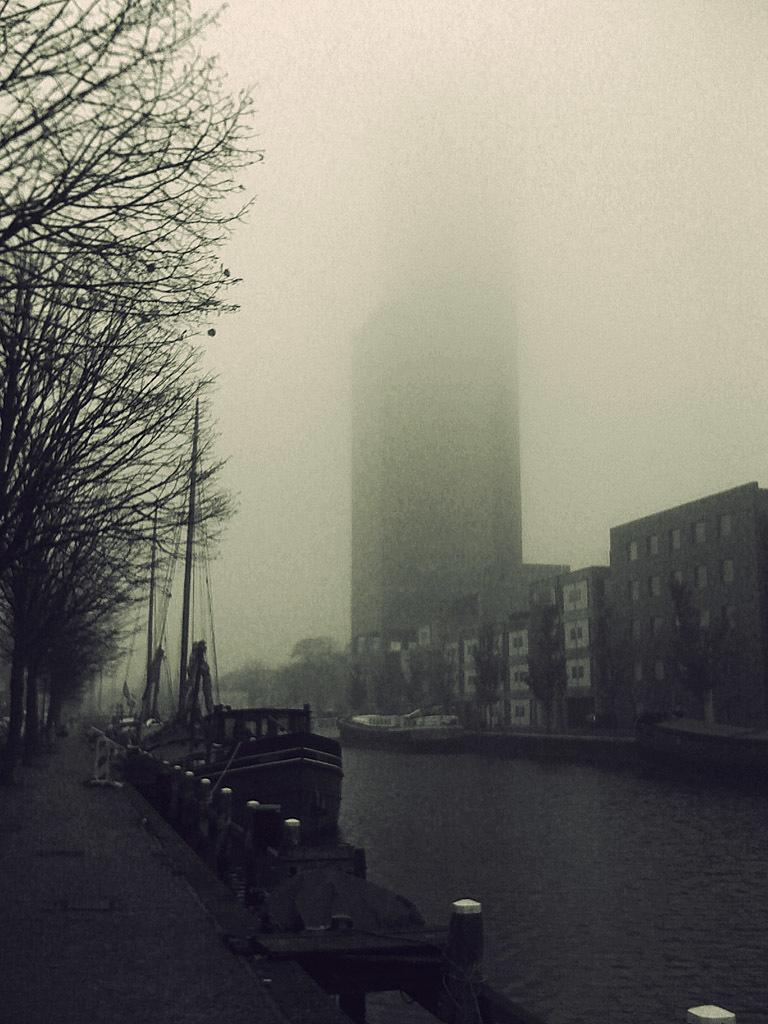What type of structures can be seen in the image? There are buildings in the image. What natural elements are present in the image? There are trees in the image. What type of barrier can be seen in the image? There is fencing in the image. What part of the natural environment is visible in the image? The sky is visible in the image. What type of vehicles can be seen on the water surface in the image? There are ships on the water surface in the image. Where are the cows grazing in the image? There are no cows present in the image. What type of trail can be seen leading to the tent in the image? There is no tent or trail present in the image. 